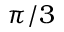<formula> <loc_0><loc_0><loc_500><loc_500>\pi / 3</formula> 